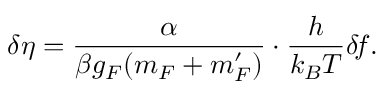Convert formula to latex. <formula><loc_0><loc_0><loc_500><loc_500>\delta \eta = \frac { \alpha } { \beta g _ { F } ( m _ { F } + m _ { F } ^ { \prime } ) } \cdot \frac { h } { k _ { B } T } \delta \, f .</formula> 